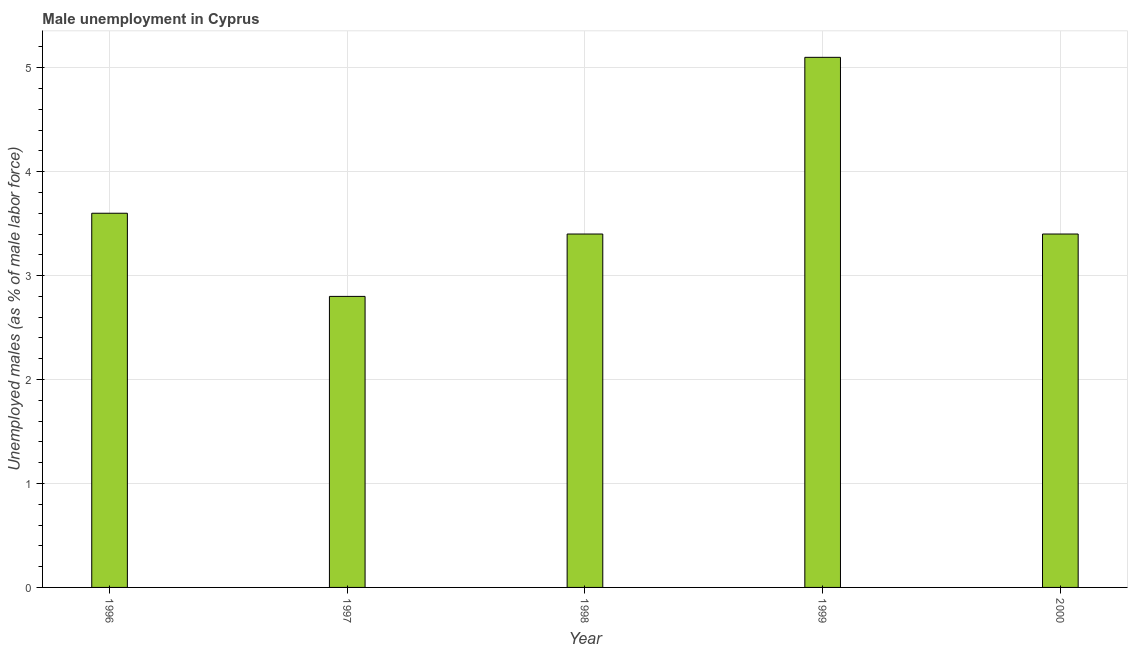Does the graph contain grids?
Offer a terse response. Yes. What is the title of the graph?
Keep it short and to the point. Male unemployment in Cyprus. What is the label or title of the Y-axis?
Give a very brief answer. Unemployed males (as % of male labor force). What is the unemployed males population in 1998?
Provide a short and direct response. 3.4. Across all years, what is the maximum unemployed males population?
Your answer should be compact. 5.1. Across all years, what is the minimum unemployed males population?
Your answer should be very brief. 2.8. In which year was the unemployed males population maximum?
Offer a terse response. 1999. In which year was the unemployed males population minimum?
Offer a very short reply. 1997. What is the sum of the unemployed males population?
Your answer should be very brief. 18.3. What is the difference between the unemployed males population in 1996 and 1999?
Your response must be concise. -1.5. What is the average unemployed males population per year?
Give a very brief answer. 3.66. What is the median unemployed males population?
Your response must be concise. 3.4. In how many years, is the unemployed males population greater than 0.4 %?
Provide a short and direct response. 5. Do a majority of the years between 2000 and 1997 (inclusive) have unemployed males population greater than 2 %?
Your answer should be very brief. Yes. What is the ratio of the unemployed males population in 1997 to that in 2000?
Ensure brevity in your answer.  0.82. Is the unemployed males population in 1997 less than that in 1999?
Provide a succinct answer. Yes. What is the difference between the highest and the second highest unemployed males population?
Offer a terse response. 1.5. Is the sum of the unemployed males population in 1998 and 2000 greater than the maximum unemployed males population across all years?
Your response must be concise. Yes. Are all the bars in the graph horizontal?
Offer a terse response. No. How many years are there in the graph?
Offer a very short reply. 5. What is the Unemployed males (as % of male labor force) in 1996?
Ensure brevity in your answer.  3.6. What is the Unemployed males (as % of male labor force) of 1997?
Ensure brevity in your answer.  2.8. What is the Unemployed males (as % of male labor force) in 1998?
Offer a very short reply. 3.4. What is the Unemployed males (as % of male labor force) of 1999?
Offer a terse response. 5.1. What is the Unemployed males (as % of male labor force) in 2000?
Make the answer very short. 3.4. What is the difference between the Unemployed males (as % of male labor force) in 1997 and 2000?
Your answer should be very brief. -0.6. What is the difference between the Unemployed males (as % of male labor force) in 1999 and 2000?
Ensure brevity in your answer.  1.7. What is the ratio of the Unemployed males (as % of male labor force) in 1996 to that in 1997?
Keep it short and to the point. 1.29. What is the ratio of the Unemployed males (as % of male labor force) in 1996 to that in 1998?
Your answer should be compact. 1.06. What is the ratio of the Unemployed males (as % of male labor force) in 1996 to that in 1999?
Offer a very short reply. 0.71. What is the ratio of the Unemployed males (as % of male labor force) in 1996 to that in 2000?
Keep it short and to the point. 1.06. What is the ratio of the Unemployed males (as % of male labor force) in 1997 to that in 1998?
Keep it short and to the point. 0.82. What is the ratio of the Unemployed males (as % of male labor force) in 1997 to that in 1999?
Provide a succinct answer. 0.55. What is the ratio of the Unemployed males (as % of male labor force) in 1997 to that in 2000?
Provide a short and direct response. 0.82. What is the ratio of the Unemployed males (as % of male labor force) in 1998 to that in 1999?
Make the answer very short. 0.67. What is the ratio of the Unemployed males (as % of male labor force) in 1998 to that in 2000?
Keep it short and to the point. 1. What is the ratio of the Unemployed males (as % of male labor force) in 1999 to that in 2000?
Your answer should be compact. 1.5. 